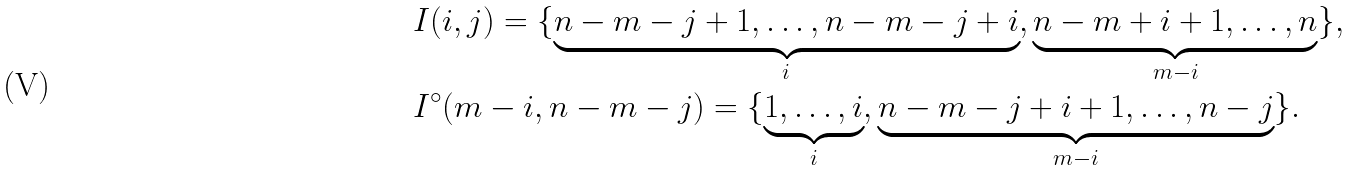<formula> <loc_0><loc_0><loc_500><loc_500>& I ( i , j ) = \{ \underbrace { n - m - j + 1 , \dots , n - m - j + i } _ { i } , \underbrace { n - m + i + 1 , \dots , n } _ { m - i } \} , \\ & I ^ { \circ } ( m - i , n - m - j ) = \{ \underbrace { 1 , \dots , i } _ { i } , \underbrace { n - m - j + i + 1 , \dots , n - j } _ { m - i } \} .</formula> 